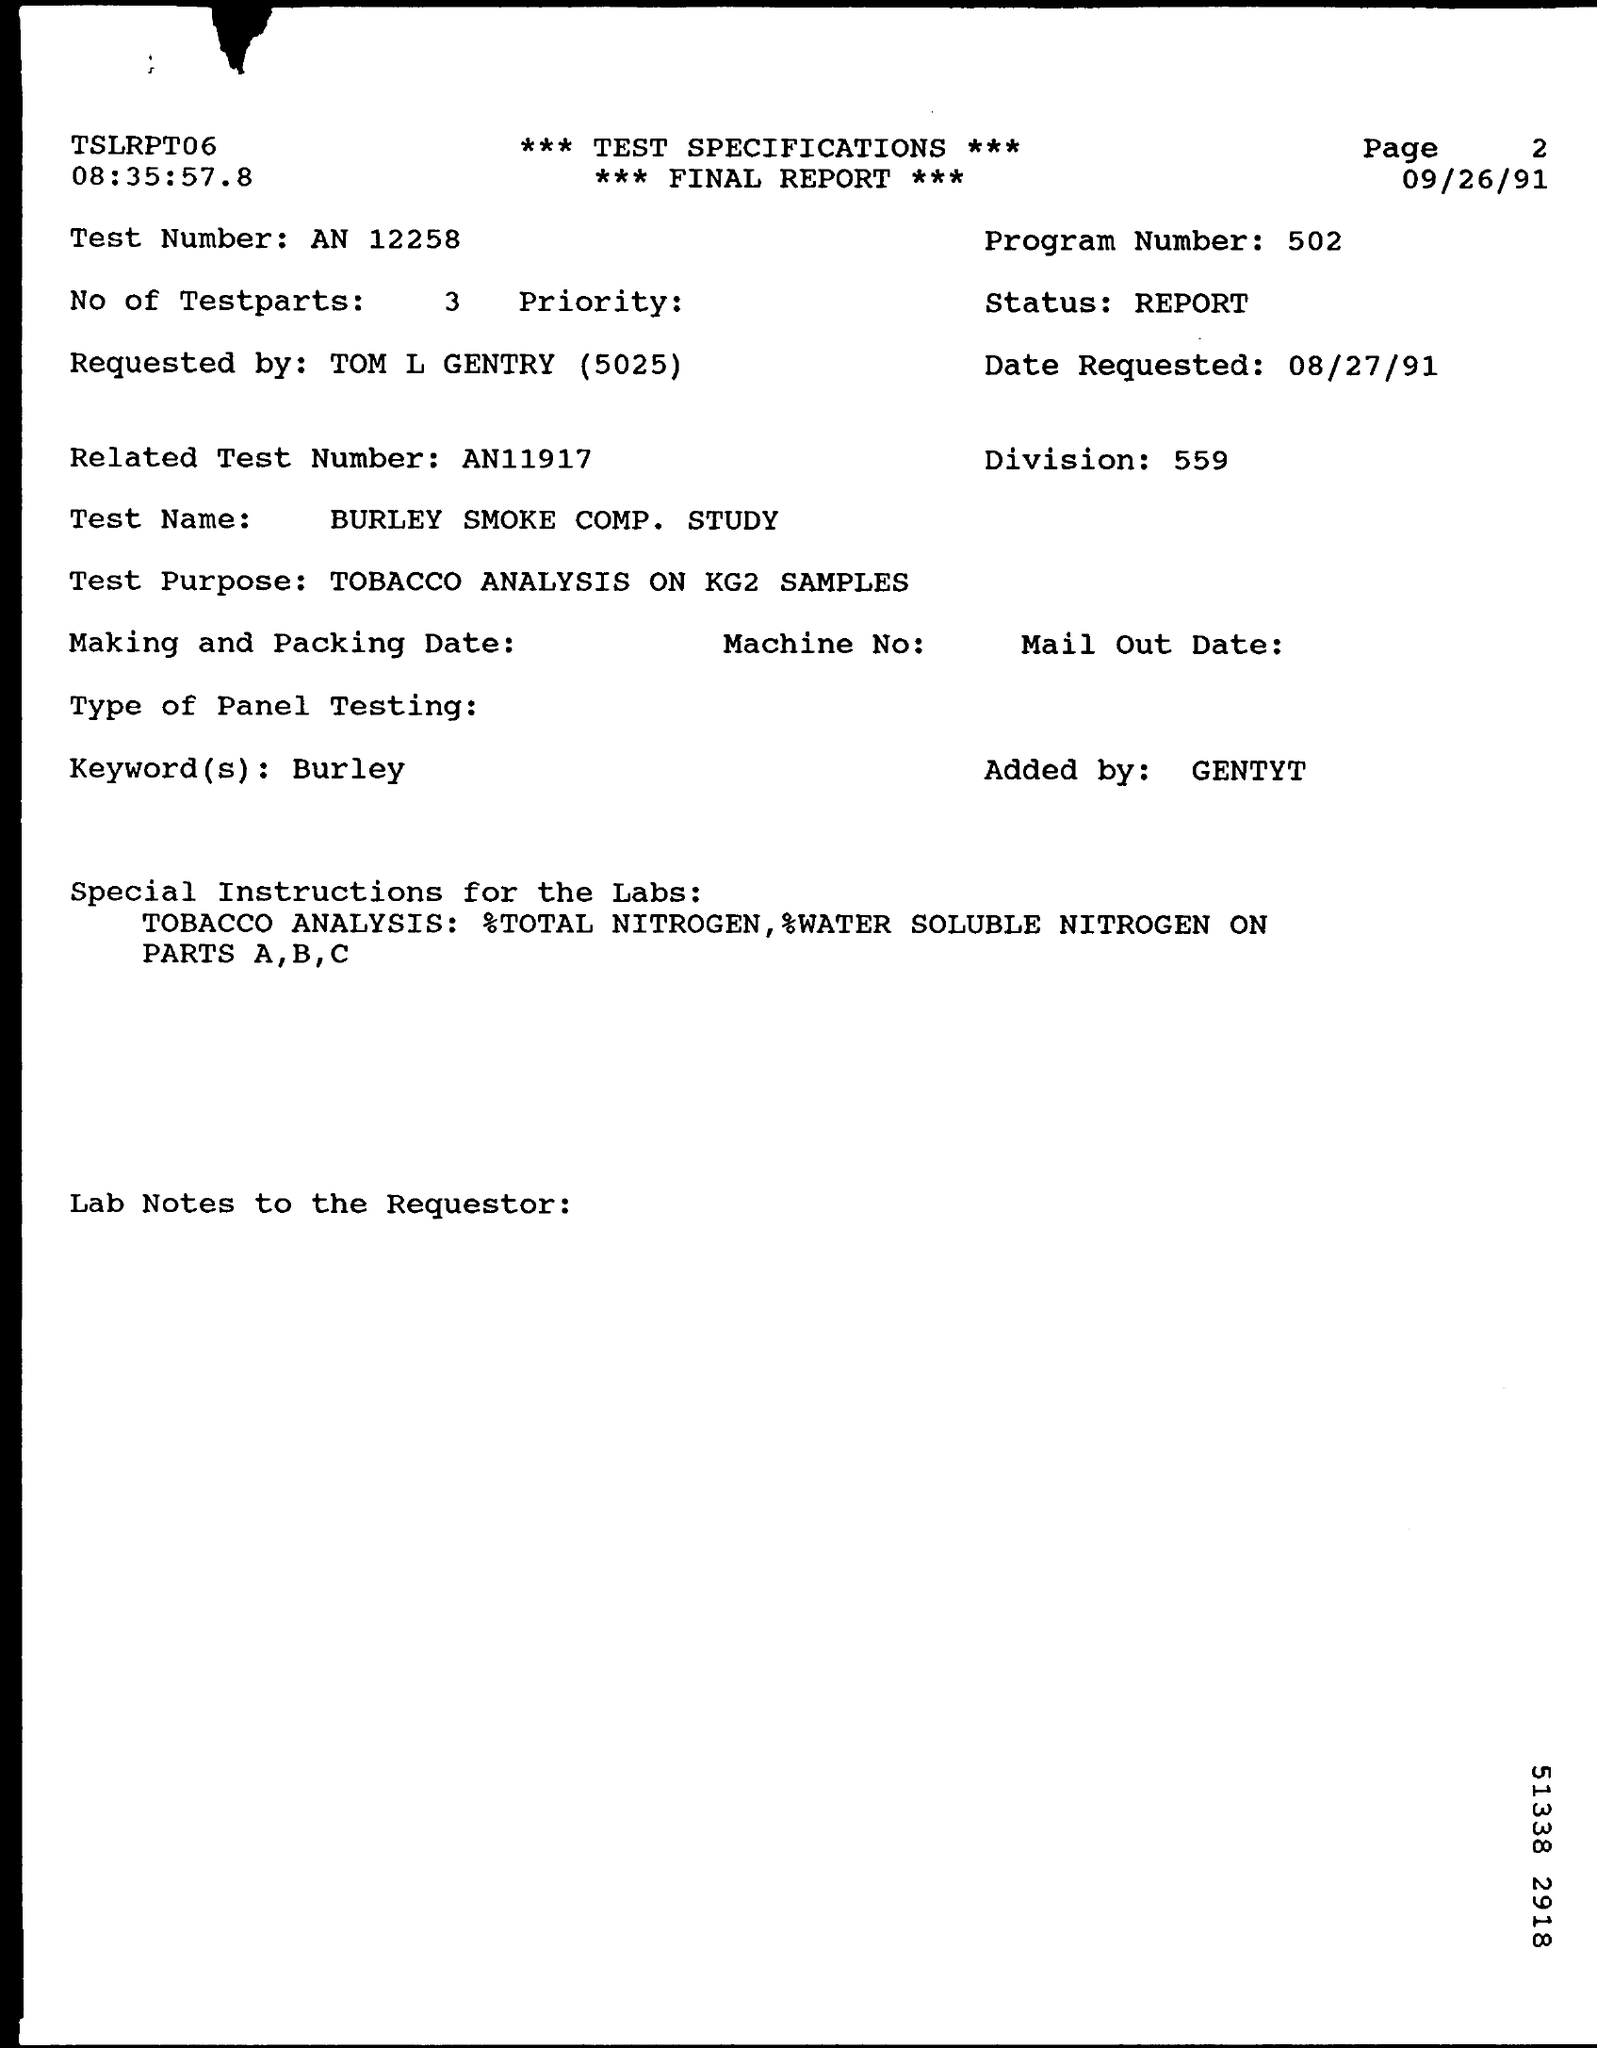What is the program number given in the final report ?
Your answer should be very brief. 502. What is the test number mentioned in the final report ?
Ensure brevity in your answer.  AN 12258. How many no of test parts are there in the final report ?
Keep it short and to the point. 3. What is the division number mentioned in the final report ?
Offer a very short reply. 559. What is the keyword(s) mentioned in the final report ?
Your answer should be very brief. Burley. What is the test name mentioned in the final report ?
Offer a terse response. Burley smoke comp. study. By whom this final report is requested by ?
Give a very brief answer. TOM L GENTRY. 